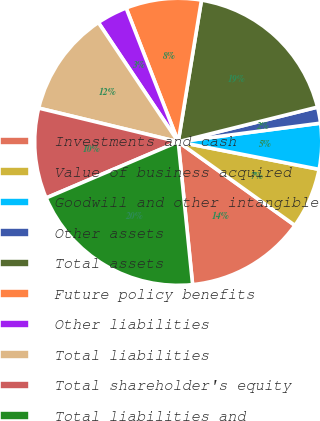Convert chart to OTSL. <chart><loc_0><loc_0><loc_500><loc_500><pie_chart><fcel>Investments and cash<fcel>Value of business acquired<fcel>Goodwill and other intangible<fcel>Other assets<fcel>Total assets<fcel>Future policy benefits<fcel>Other liabilities<fcel>Total liabilities<fcel>Total shareholder's equity<fcel>Total liabilities and<nl><fcel>13.51%<fcel>6.82%<fcel>5.15%<fcel>1.81%<fcel>18.53%<fcel>8.5%<fcel>3.48%<fcel>11.84%<fcel>10.17%<fcel>20.2%<nl></chart> 